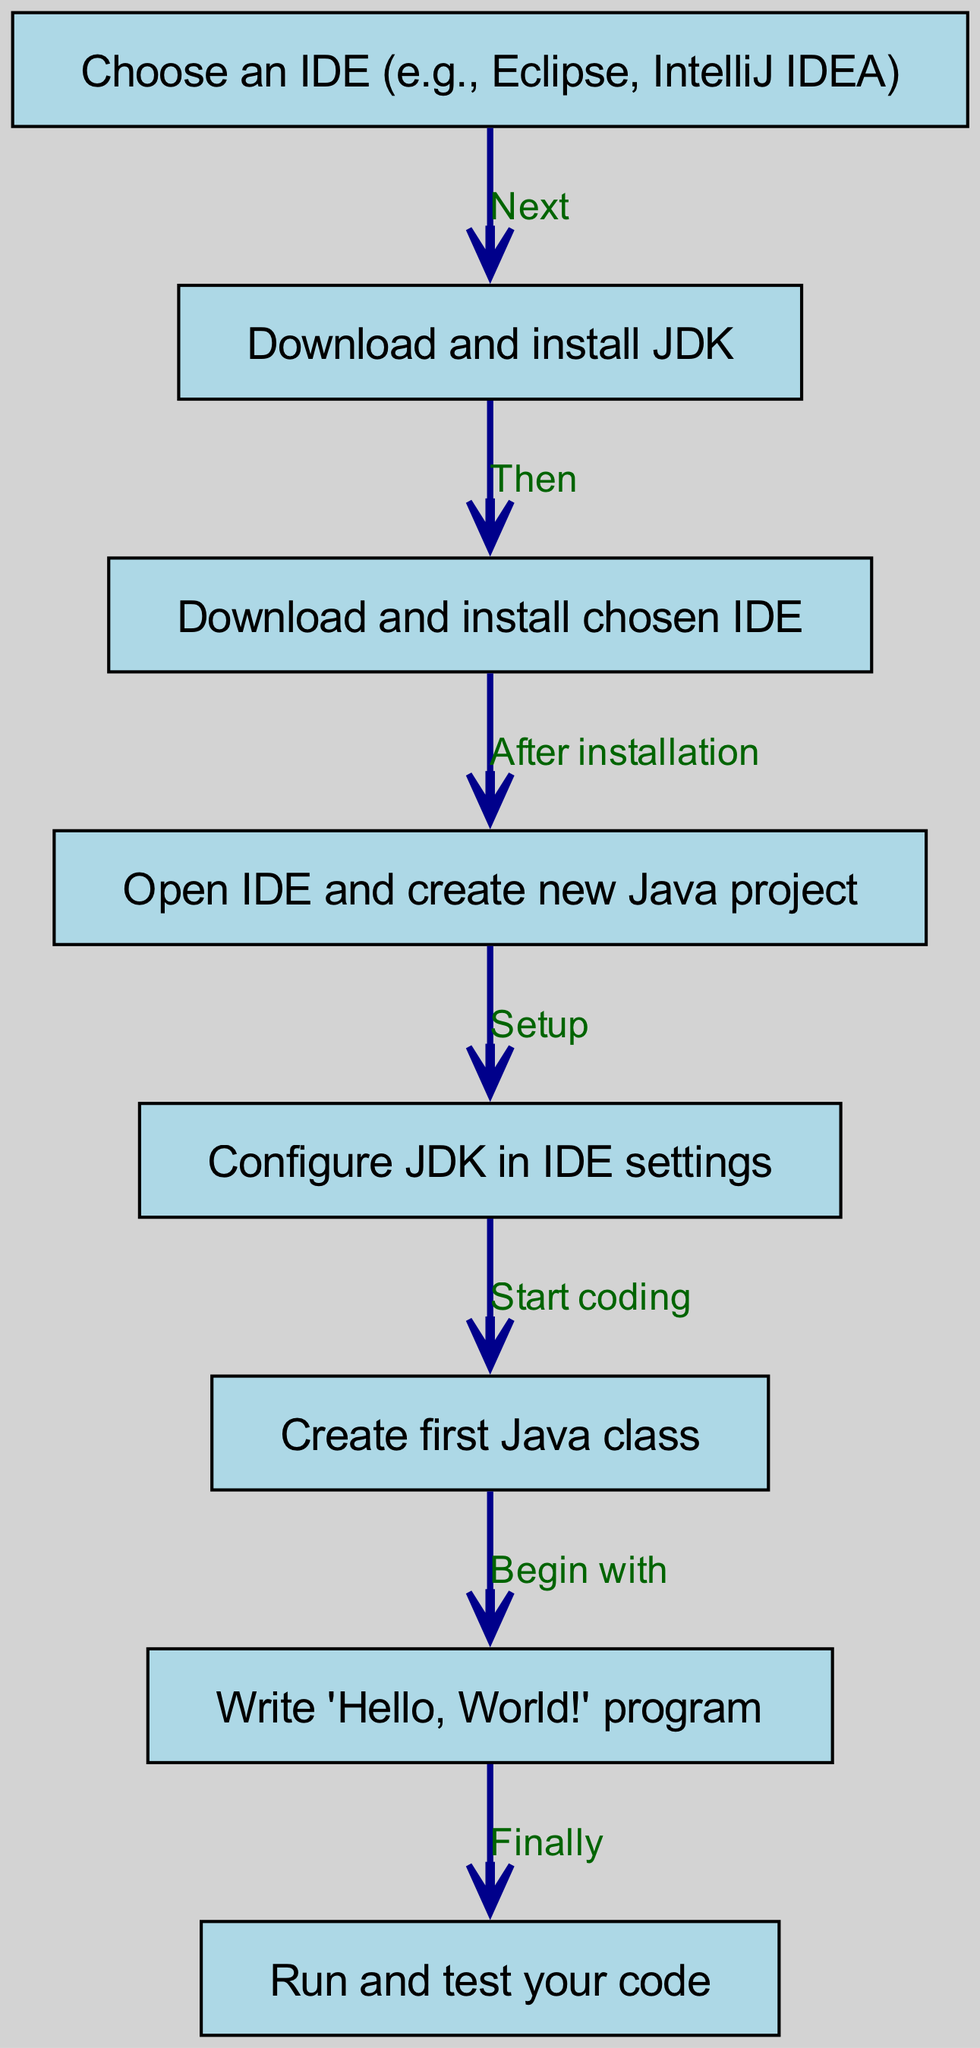What is the first step in setting up the IDE? The first node in the diagram states "Choose an IDE (e.g., Eclipse, IntelliJ IDEA)", indicating that this is the starting point of the flow.
Answer: Choose an IDE How many total nodes are there in the diagram? By counting each unique step represented as nodes, there are eight nodes listed in the diagram.
Answer: Eight What action follows after downloading and installing the JDK? The diagram shows an arrow labeled "Then" leading from the JDK installation node to "Download and install chosen IDE", indicating that this is the next action.
Answer: Download and install chosen IDE What is the final action you take after writing the program? The flow leads from "Write 'Hello, World!' program" to "Run and test your code", marking this as the concluding action.
Answer: Run and test your code What is the relationship between "Open IDE and create new Java project" and "Configure JDK in IDE settings"? The edge from "Open IDE and create new Java project" to "Configure JDK in IDE settings" is marked "Setup", indicating that configuring the JDK follows the creation of a new project.
Answer: Setup What is the connection between creating the first Java class and writing the "Hello, World!" program? The edge from "Create first Java class" labeled "Begin with" indicates that writing the "Hello, World!" program follows after this step.
Answer: Begin with Which step involves installing software? The steps that involve installation are "Download and install JDK" and "Download and install chosen IDE", both of which directly mention installation processes.
Answer: Download and install JDK What step follows after choosing the IDE? The flow diagram indicates that after choosing the IDE, the next step is to "Download and install JDK", which is linked with the edge labeled "Next".
Answer: Download and install JDK 